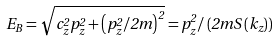Convert formula to latex. <formula><loc_0><loc_0><loc_500><loc_500>E _ { B } = \sqrt { c _ { z } ^ { 2 } p _ { z } ^ { 2 } + \left ( p _ { z } ^ { 2 } / 2 m \right ) ^ { 2 } } = p _ { z } ^ { 2 } / \left ( 2 m S \left ( k _ { z } \right ) \right )</formula> 